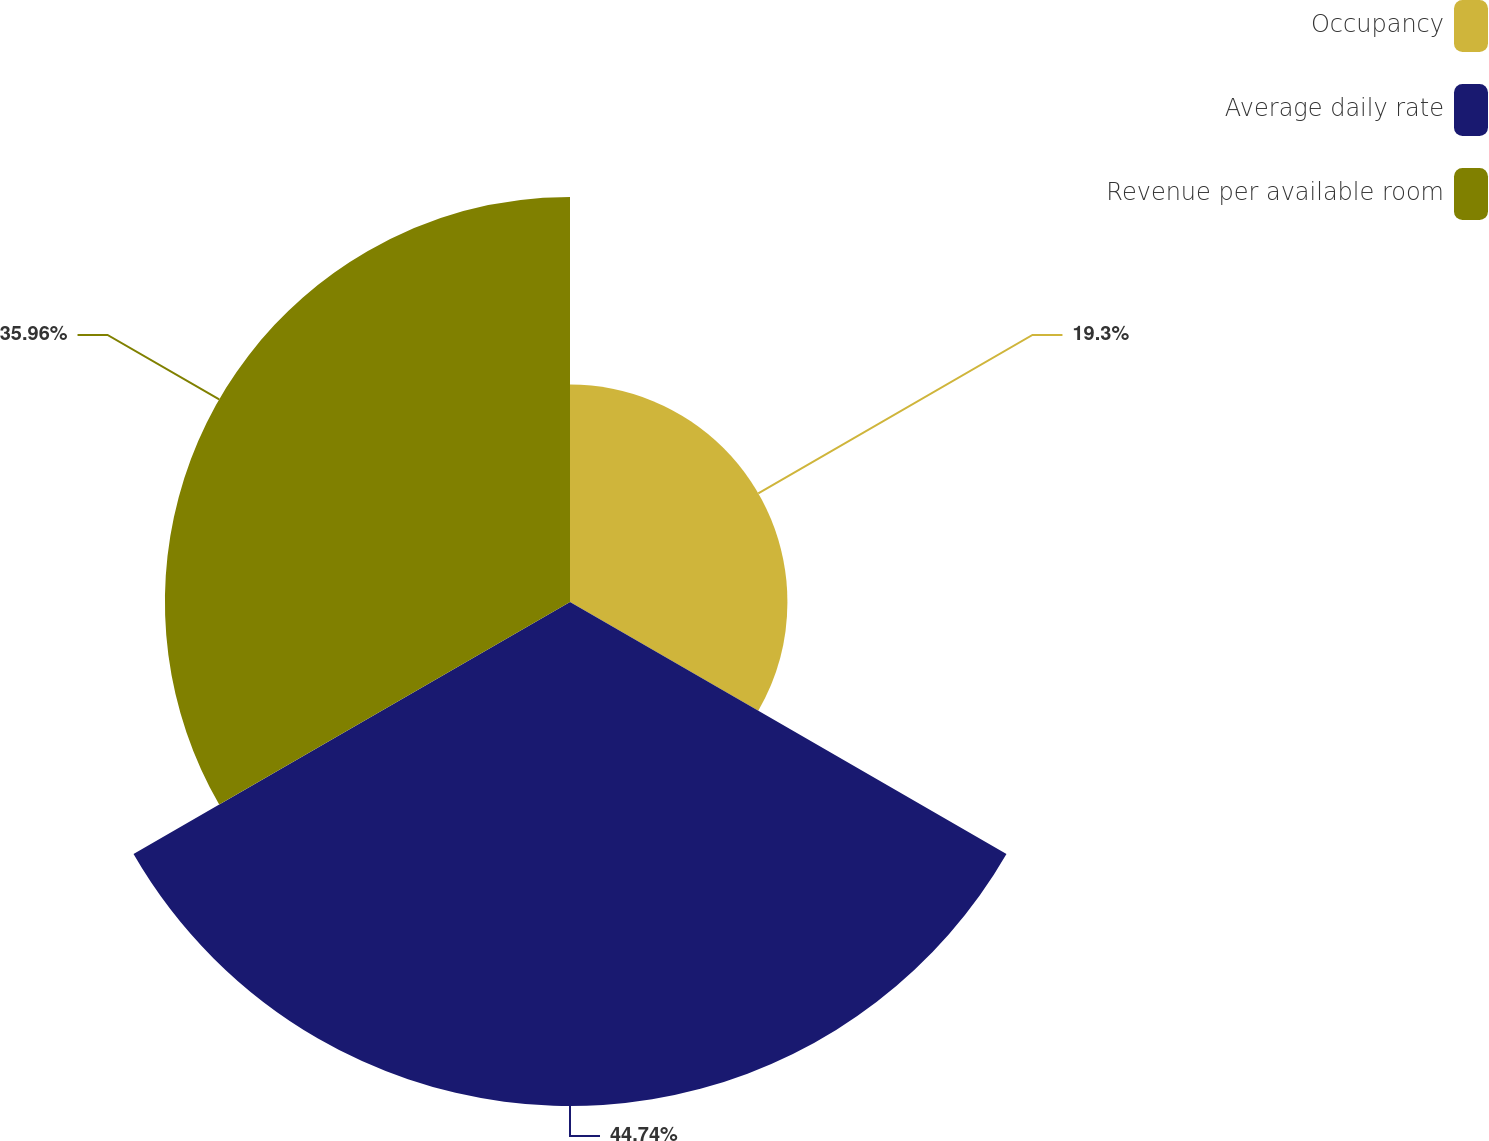Convert chart. <chart><loc_0><loc_0><loc_500><loc_500><pie_chart><fcel>Occupancy<fcel>Average daily rate<fcel>Revenue per available room<nl><fcel>19.3%<fcel>44.74%<fcel>35.96%<nl></chart> 